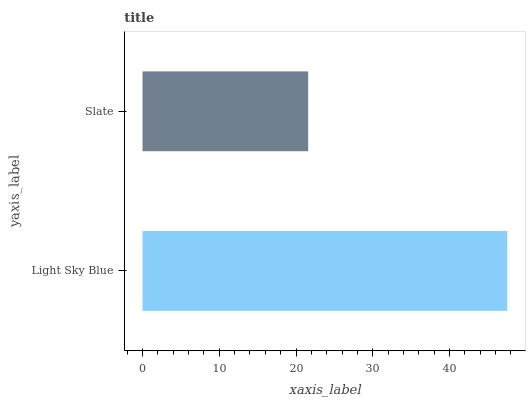Is Slate the minimum?
Answer yes or no. Yes. Is Light Sky Blue the maximum?
Answer yes or no. Yes. Is Slate the maximum?
Answer yes or no. No. Is Light Sky Blue greater than Slate?
Answer yes or no. Yes. Is Slate less than Light Sky Blue?
Answer yes or no. Yes. Is Slate greater than Light Sky Blue?
Answer yes or no. No. Is Light Sky Blue less than Slate?
Answer yes or no. No. Is Light Sky Blue the high median?
Answer yes or no. Yes. Is Slate the low median?
Answer yes or no. Yes. Is Slate the high median?
Answer yes or no. No. Is Light Sky Blue the low median?
Answer yes or no. No. 